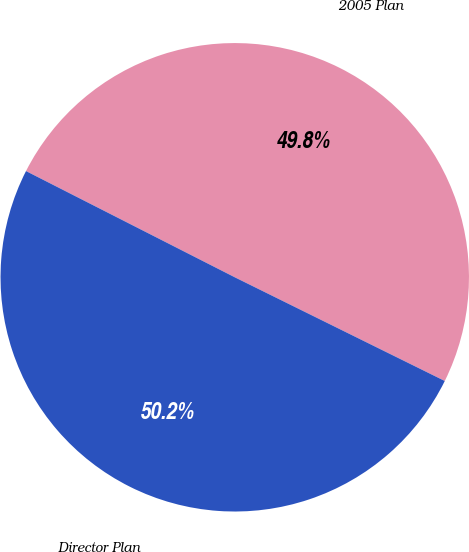<chart> <loc_0><loc_0><loc_500><loc_500><pie_chart><fcel>2005 Plan<fcel>Director Plan<nl><fcel>49.81%<fcel>50.19%<nl></chart> 